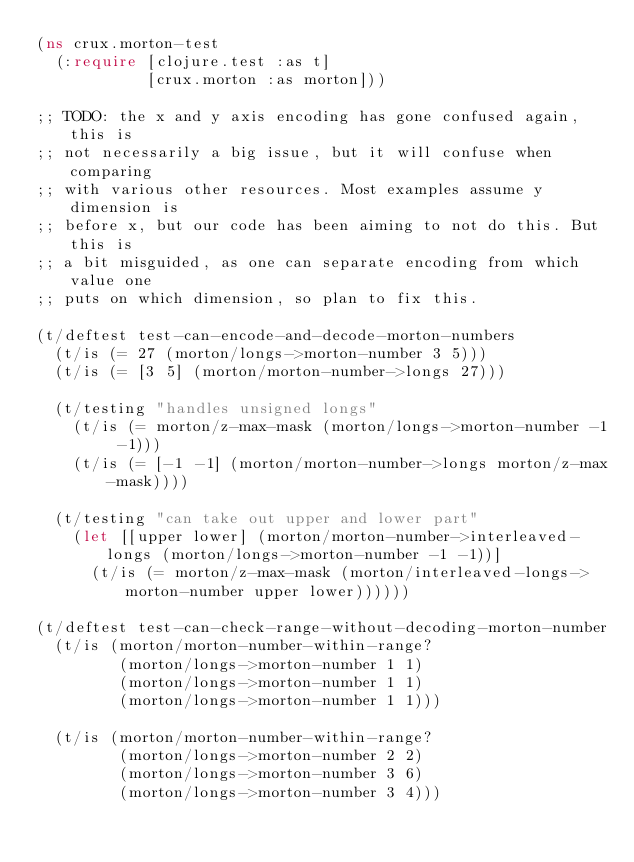<code> <loc_0><loc_0><loc_500><loc_500><_Clojure_>(ns crux.morton-test
  (:require [clojure.test :as t]
            [crux.morton :as morton]))

;; TODO: the x and y axis encoding has gone confused again, this is
;; not necessarily a big issue, but it will confuse when comparing
;; with various other resources. Most examples assume y dimension is
;; before x, but our code has been aiming to not do this. But this is
;; a bit misguided, as one can separate encoding from which value one
;; puts on which dimension, so plan to fix this.

(t/deftest test-can-encode-and-decode-morton-numbers
  (t/is (= 27 (morton/longs->morton-number 3 5)))
  (t/is (= [3 5] (morton/morton-number->longs 27)))

  (t/testing "handles unsigned longs"
    (t/is (= morton/z-max-mask (morton/longs->morton-number -1 -1)))
    (t/is (= [-1 -1] (morton/morton-number->longs morton/z-max-mask))))

  (t/testing "can take out upper and lower part"
    (let [[upper lower] (morton/morton-number->interleaved-longs (morton/longs->morton-number -1 -1))]
      (t/is (= morton/z-max-mask (morton/interleaved-longs->morton-number upper lower))))))

(t/deftest test-can-check-range-without-decoding-morton-number
  (t/is (morton/morton-number-within-range?
         (morton/longs->morton-number 1 1)
         (morton/longs->morton-number 1 1)
         (morton/longs->morton-number 1 1)))

  (t/is (morton/morton-number-within-range?
         (morton/longs->morton-number 2 2)
         (morton/longs->morton-number 3 6)
         (morton/longs->morton-number 3 4)))
</code> 